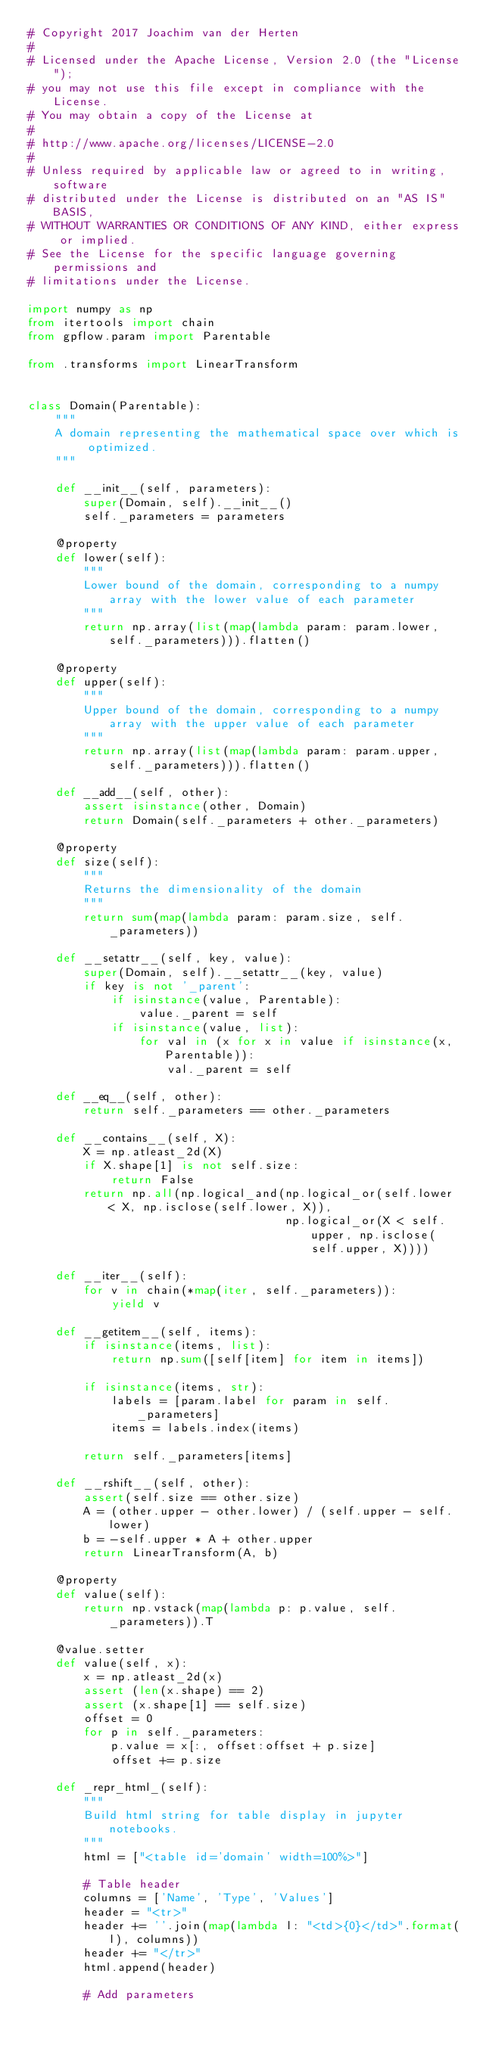<code> <loc_0><loc_0><loc_500><loc_500><_Python_># Copyright 2017 Joachim van der Herten
#
# Licensed under the Apache License, Version 2.0 (the "License");
# you may not use this file except in compliance with the License.
# You may obtain a copy of the License at
#
# http://www.apache.org/licenses/LICENSE-2.0
#
# Unless required by applicable law or agreed to in writing, software
# distributed under the License is distributed on an "AS IS" BASIS,
# WITHOUT WARRANTIES OR CONDITIONS OF ANY KIND, either express or implied.
# See the License for the specific language governing permissions and
# limitations under the License.

import numpy as np
from itertools import chain
from gpflow.param import Parentable

from .transforms import LinearTransform


class Domain(Parentable):
    """
    A domain representing the mathematical space over which is optimized.
    """

    def __init__(self, parameters):
        super(Domain, self).__init__()
        self._parameters = parameters

    @property
    def lower(self):
        """
        Lower bound of the domain, corresponding to a numpy array with the lower value of each parameter
        """
        return np.array(list(map(lambda param: param.lower, self._parameters))).flatten()

    @property
    def upper(self):
        """
        Upper bound of the domain, corresponding to a numpy array with the upper value of each parameter
        """
        return np.array(list(map(lambda param: param.upper, self._parameters))).flatten()

    def __add__(self, other):
        assert isinstance(other, Domain)
        return Domain(self._parameters + other._parameters)

    @property
    def size(self):
        """
        Returns the dimensionality of the domain
        """
        return sum(map(lambda param: param.size, self._parameters))

    def __setattr__(self, key, value):
        super(Domain, self).__setattr__(key, value)
        if key is not '_parent':
            if isinstance(value, Parentable):
                value._parent = self
            if isinstance(value, list):
                for val in (x for x in value if isinstance(x, Parentable)):
                    val._parent = self

    def __eq__(self, other):
        return self._parameters == other._parameters

    def __contains__(self, X):
        X = np.atleast_2d(X)
        if X.shape[1] is not self.size:
            return False
        return np.all(np.logical_and(np.logical_or(self.lower < X, np.isclose(self.lower, X)),
                                     np.logical_or(X < self.upper, np.isclose(self.upper, X))))

    def __iter__(self):
        for v in chain(*map(iter, self._parameters)):
            yield v

    def __getitem__(self, items):
        if isinstance(items, list):
            return np.sum([self[item] for item in items])

        if isinstance(items, str):
            labels = [param.label for param in self._parameters]
            items = labels.index(items)

        return self._parameters[items]

    def __rshift__(self, other):
        assert(self.size == other.size)
        A = (other.upper - other.lower) / (self.upper - self.lower)
        b = -self.upper * A + other.upper
        return LinearTransform(A, b)

    @property
    def value(self):
        return np.vstack(map(lambda p: p.value, self._parameters)).T

    @value.setter
    def value(self, x):
        x = np.atleast_2d(x)
        assert (len(x.shape) == 2)
        assert (x.shape[1] == self.size)
        offset = 0
        for p in self._parameters:
            p.value = x[:, offset:offset + p.size]
            offset += p.size

    def _repr_html_(self):
        """
        Build html string for table display in jupyter notebooks.
        """
        html = ["<table id='domain' width=100%>"]

        # Table header
        columns = ['Name', 'Type', 'Values']
        header = "<tr>"
        header += ''.join(map(lambda l: "<td>{0}</td>".format(l), columns))
        header += "</tr>"
        html.append(header)

        # Add parameters</code> 